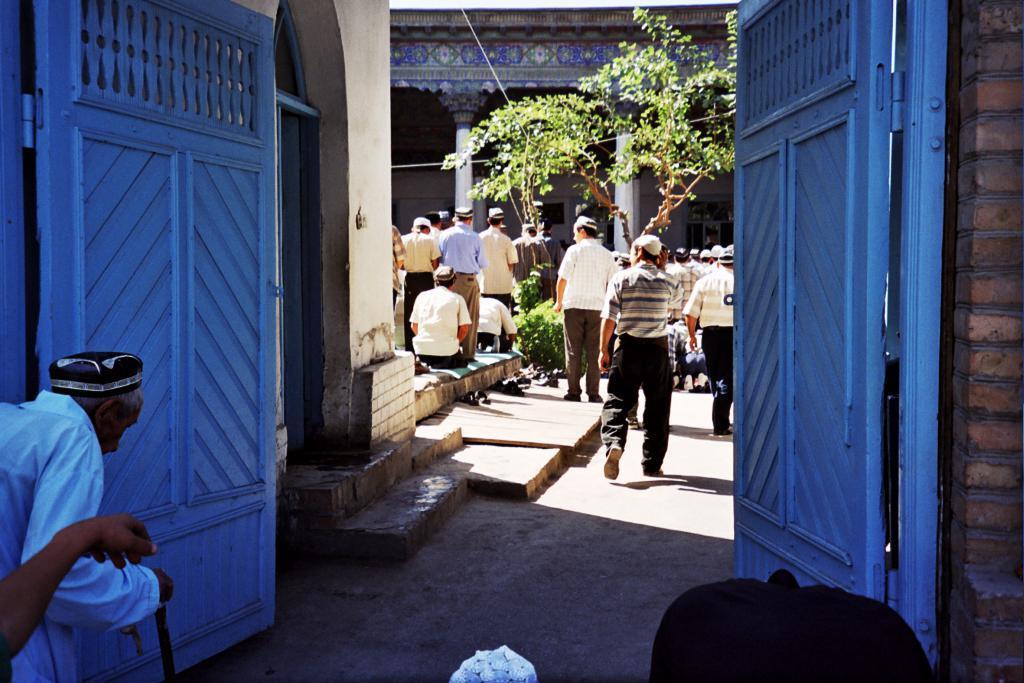Can you describe this image briefly? There is an old man and another person on the left side of the image and there are people and plants in the center and there are doors on both the sides, there are wires, windows and pillars in the background area, it seems like unclear objects at the bottom side. 